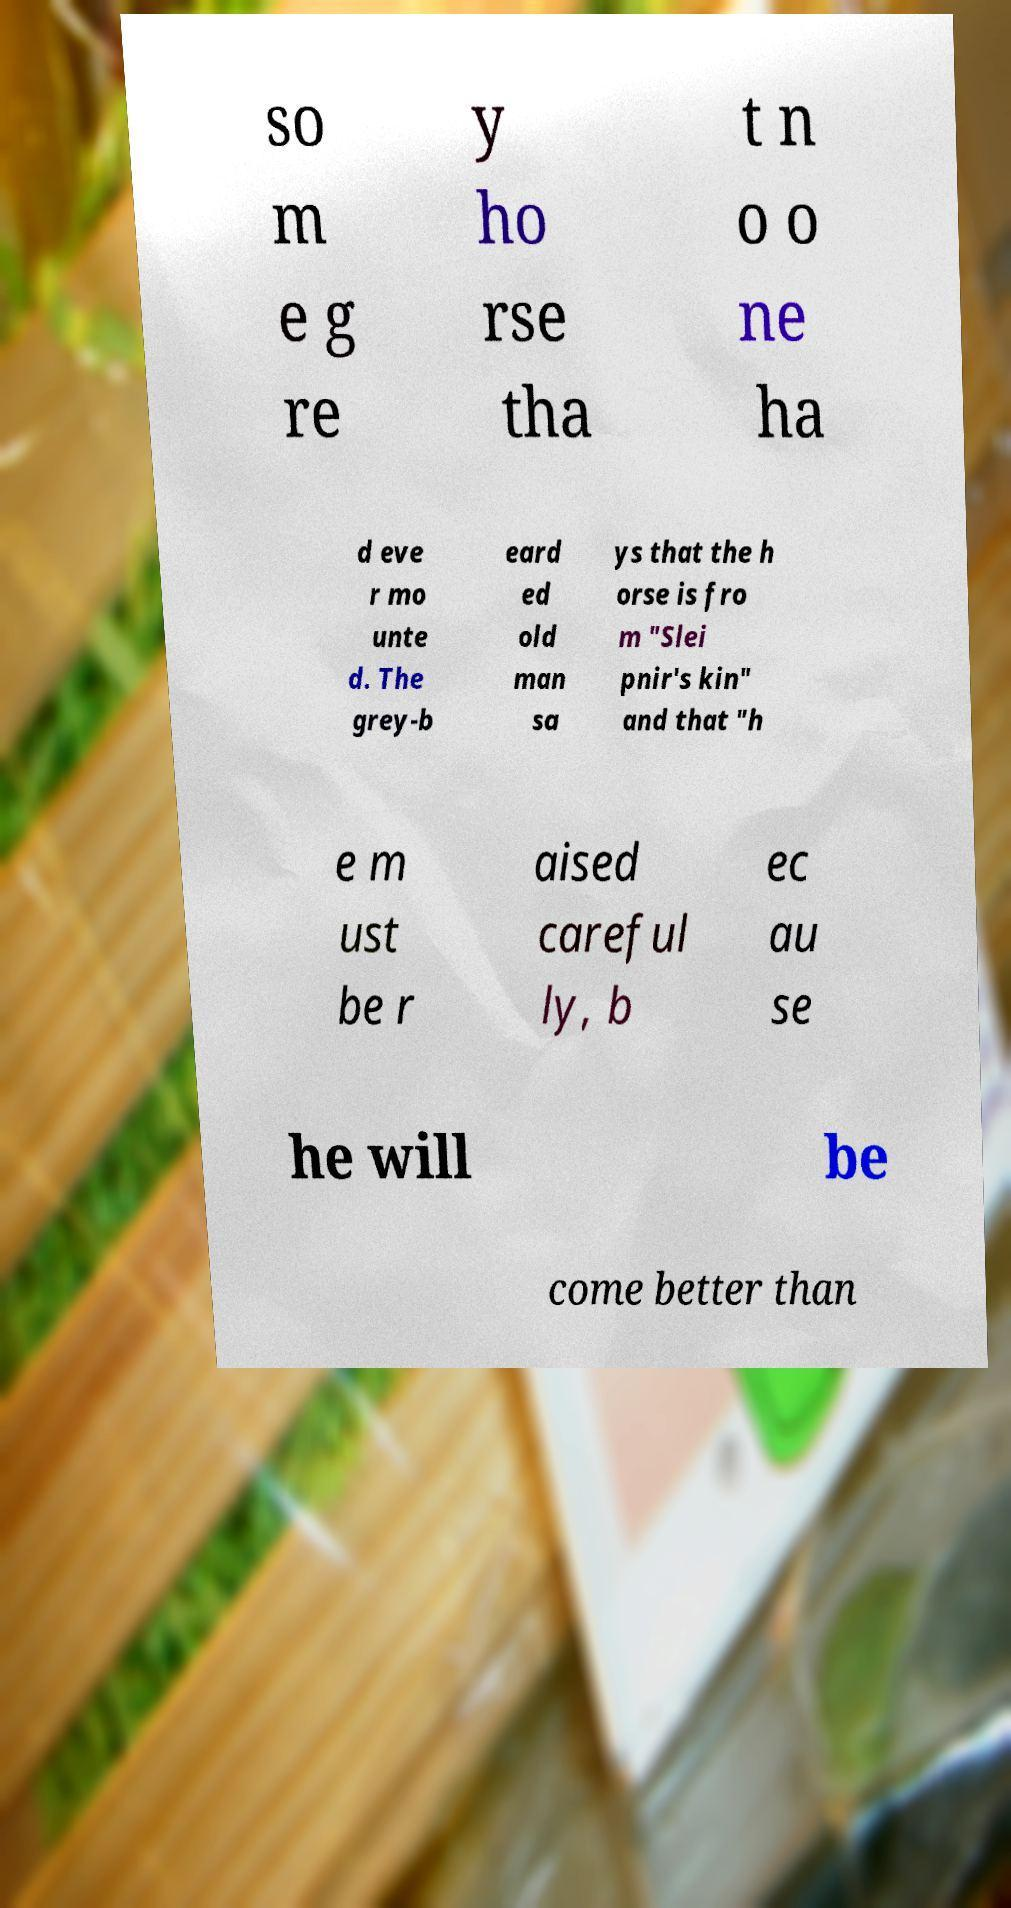Please identify and transcribe the text found in this image. so m e g re y ho rse tha t n o o ne ha d eve r mo unte d. The grey-b eard ed old man sa ys that the h orse is fro m "Slei pnir's kin" and that "h e m ust be r aised careful ly, b ec au se he will be come better than 